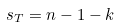<formula> <loc_0><loc_0><loc_500><loc_500>s _ { T } = n - 1 - k</formula> 